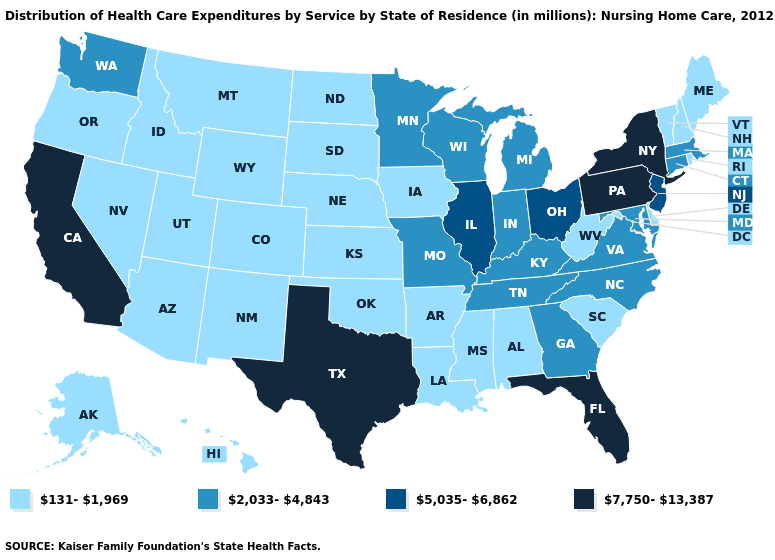Does New York have the lowest value in the USA?
Short answer required. No. Does the map have missing data?
Give a very brief answer. No. What is the value of Indiana?
Be succinct. 2,033-4,843. Does Georgia have the same value as Tennessee?
Answer briefly. Yes. Name the states that have a value in the range 7,750-13,387?
Concise answer only. California, Florida, New York, Pennsylvania, Texas. What is the value of Vermont?
Answer briefly. 131-1,969. Which states have the lowest value in the West?
Short answer required. Alaska, Arizona, Colorado, Hawaii, Idaho, Montana, Nevada, New Mexico, Oregon, Utah, Wyoming. Does Kentucky have the same value as Connecticut?
Quick response, please. Yes. What is the value of Massachusetts?
Short answer required. 2,033-4,843. What is the lowest value in the MidWest?
Keep it brief. 131-1,969. What is the lowest value in the USA?
Write a very short answer. 131-1,969. Name the states that have a value in the range 131-1,969?
Give a very brief answer. Alabama, Alaska, Arizona, Arkansas, Colorado, Delaware, Hawaii, Idaho, Iowa, Kansas, Louisiana, Maine, Mississippi, Montana, Nebraska, Nevada, New Hampshire, New Mexico, North Dakota, Oklahoma, Oregon, Rhode Island, South Carolina, South Dakota, Utah, Vermont, West Virginia, Wyoming. What is the value of Florida?
Keep it brief. 7,750-13,387. What is the value of Kansas?
Write a very short answer. 131-1,969. 